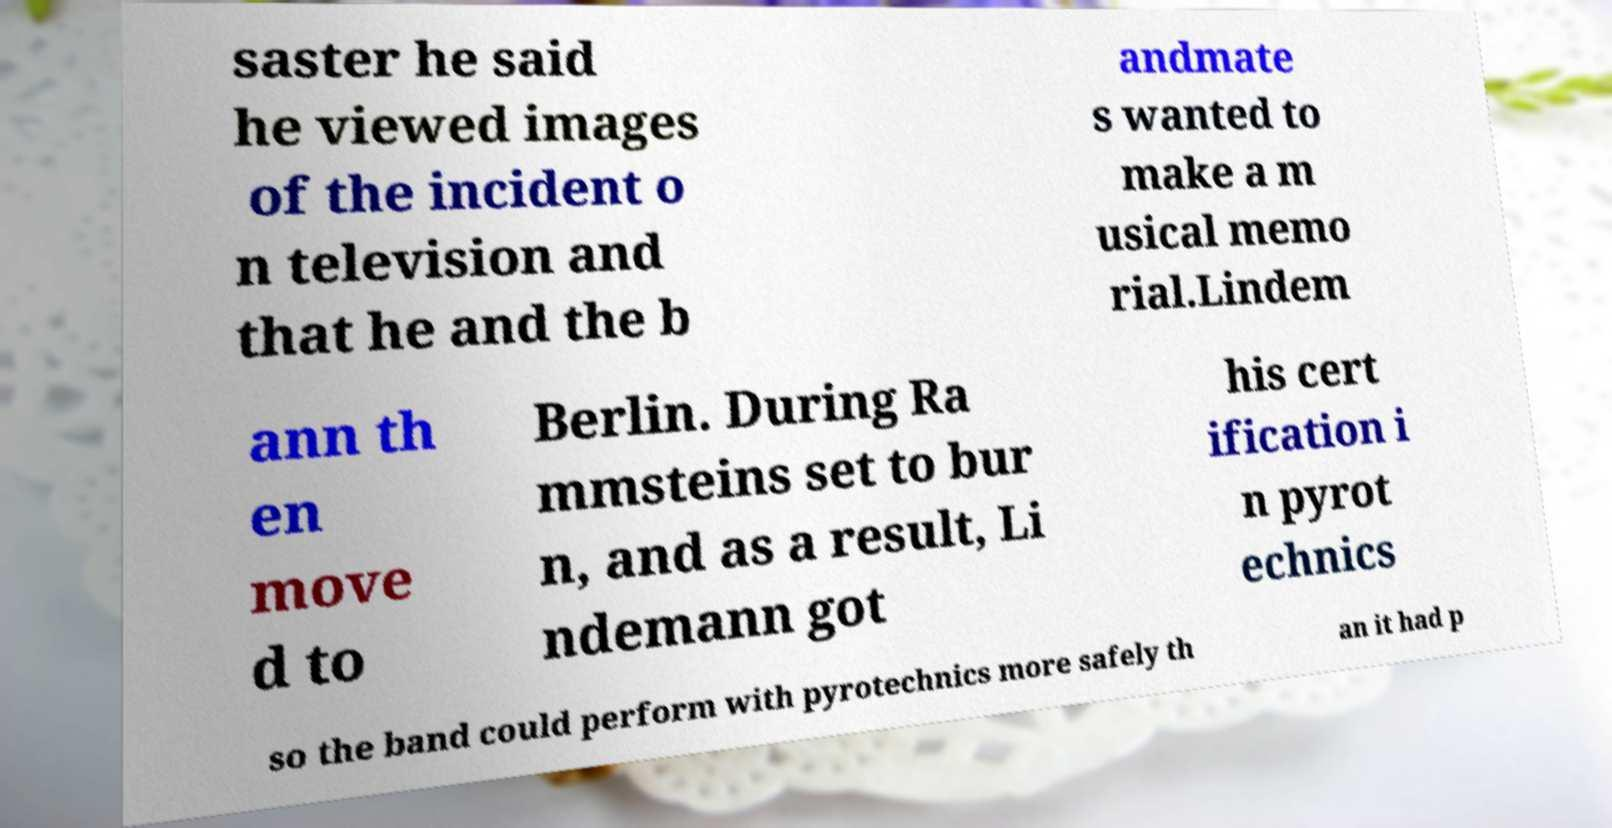Can you accurately transcribe the text from the provided image for me? saster he said he viewed images of the incident o n television and that he and the b andmate s wanted to make a m usical memo rial.Lindem ann th en move d to Berlin. During Ra mmsteins set to bur n, and as a result, Li ndemann got his cert ification i n pyrot echnics so the band could perform with pyrotechnics more safely th an it had p 